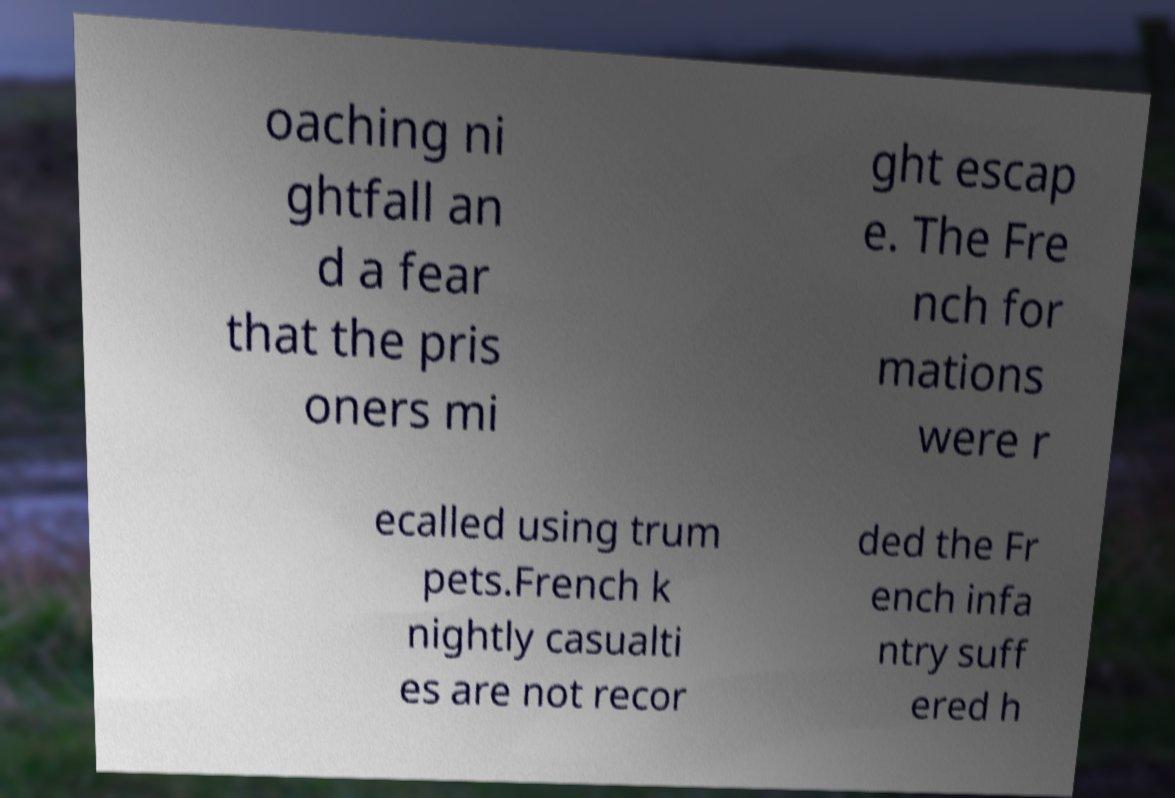What messages or text are displayed in this image? I need them in a readable, typed format. oaching ni ghtfall an d a fear that the pris oners mi ght escap e. The Fre nch for mations were r ecalled using trum pets.French k nightly casualti es are not recor ded the Fr ench infa ntry suff ered h 